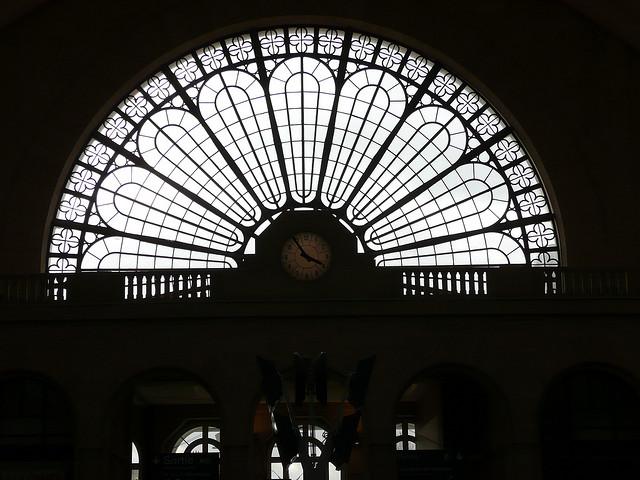How many clocks are on the building?
Write a very short answer. 1. What shape are the holes in the ceiling?
Answer briefly. Square. What time is it?
Give a very brief answer. 3:55. What color is the window?
Write a very short answer. Black. 